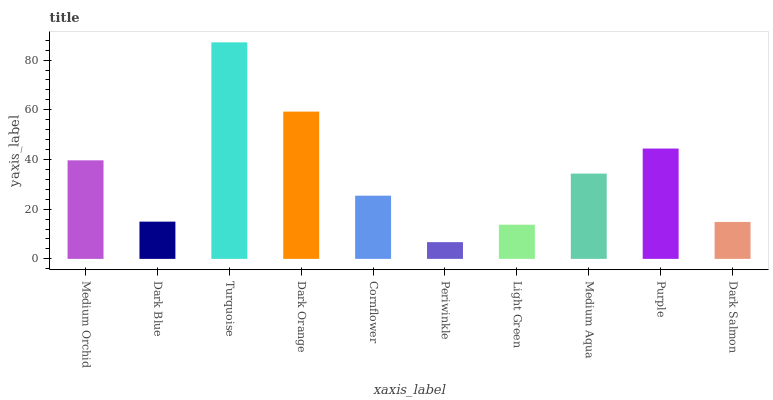Is Periwinkle the minimum?
Answer yes or no. Yes. Is Turquoise the maximum?
Answer yes or no. Yes. Is Dark Blue the minimum?
Answer yes or no. No. Is Dark Blue the maximum?
Answer yes or no. No. Is Medium Orchid greater than Dark Blue?
Answer yes or no. Yes. Is Dark Blue less than Medium Orchid?
Answer yes or no. Yes. Is Dark Blue greater than Medium Orchid?
Answer yes or no. No. Is Medium Orchid less than Dark Blue?
Answer yes or no. No. Is Medium Aqua the high median?
Answer yes or no. Yes. Is Cornflower the low median?
Answer yes or no. Yes. Is Purple the high median?
Answer yes or no. No. Is Turquoise the low median?
Answer yes or no. No. 